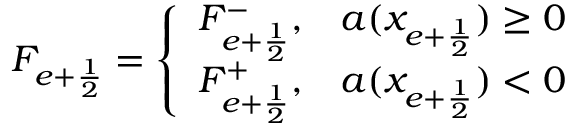Convert formula to latex. <formula><loc_0><loc_0><loc_500><loc_500>F _ { e + \frac { 1 } { 2 } } = \left \{ \begin{array} { l l } { F _ { e + \frac { 1 } { 2 } } ^ { - } , } & { a ( x _ { e + \frac { 1 } { 2 } } ) \geq 0 } \\ { F _ { e + \frac { 1 } { 2 } } ^ { + } , } & { a ( x _ { e + \frac { 1 } { 2 } } ) < 0 } \end{array}</formula> 